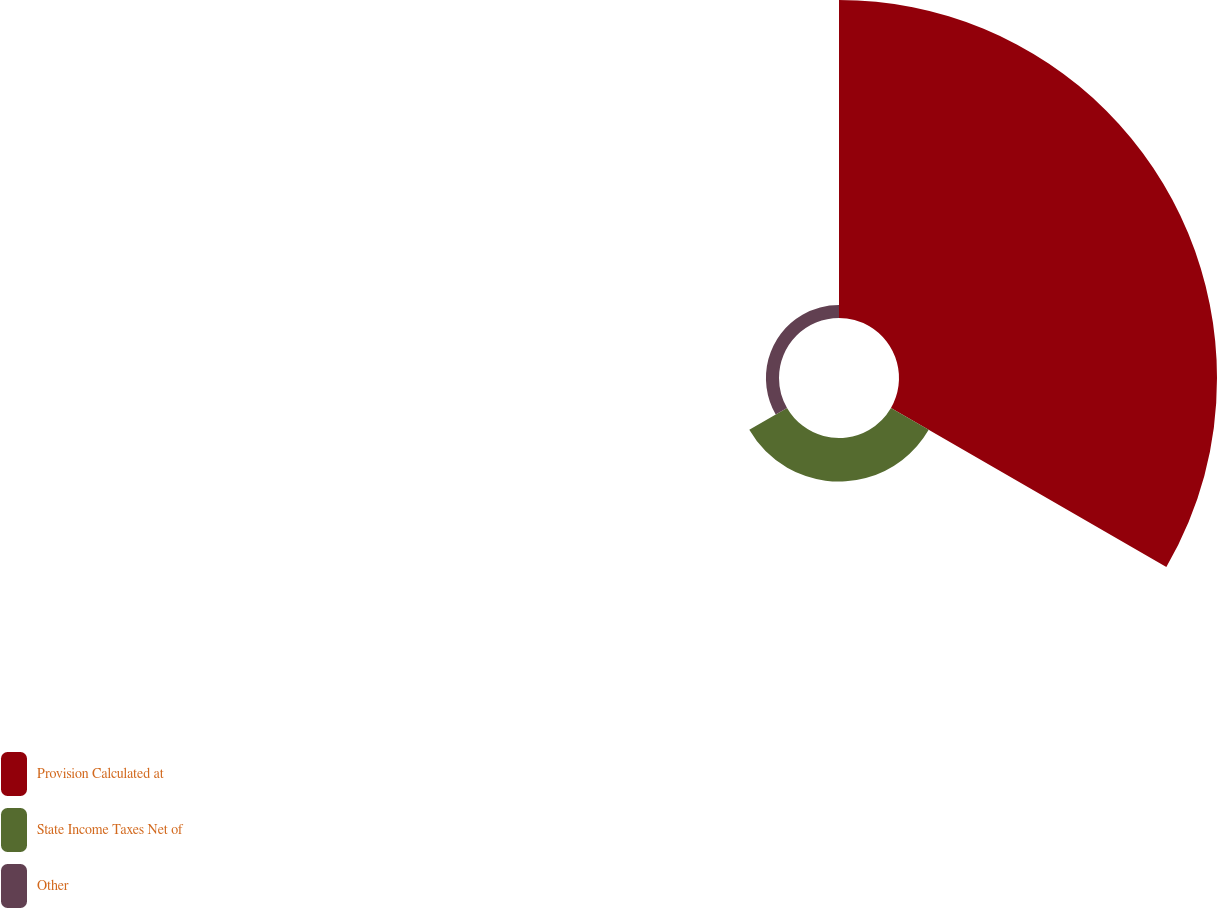Convert chart to OTSL. <chart><loc_0><loc_0><loc_500><loc_500><pie_chart><fcel>Provision Calculated at<fcel>State Income Taxes Net of<fcel>Other<nl><fcel>84.88%<fcel>11.63%<fcel>3.49%<nl></chart> 